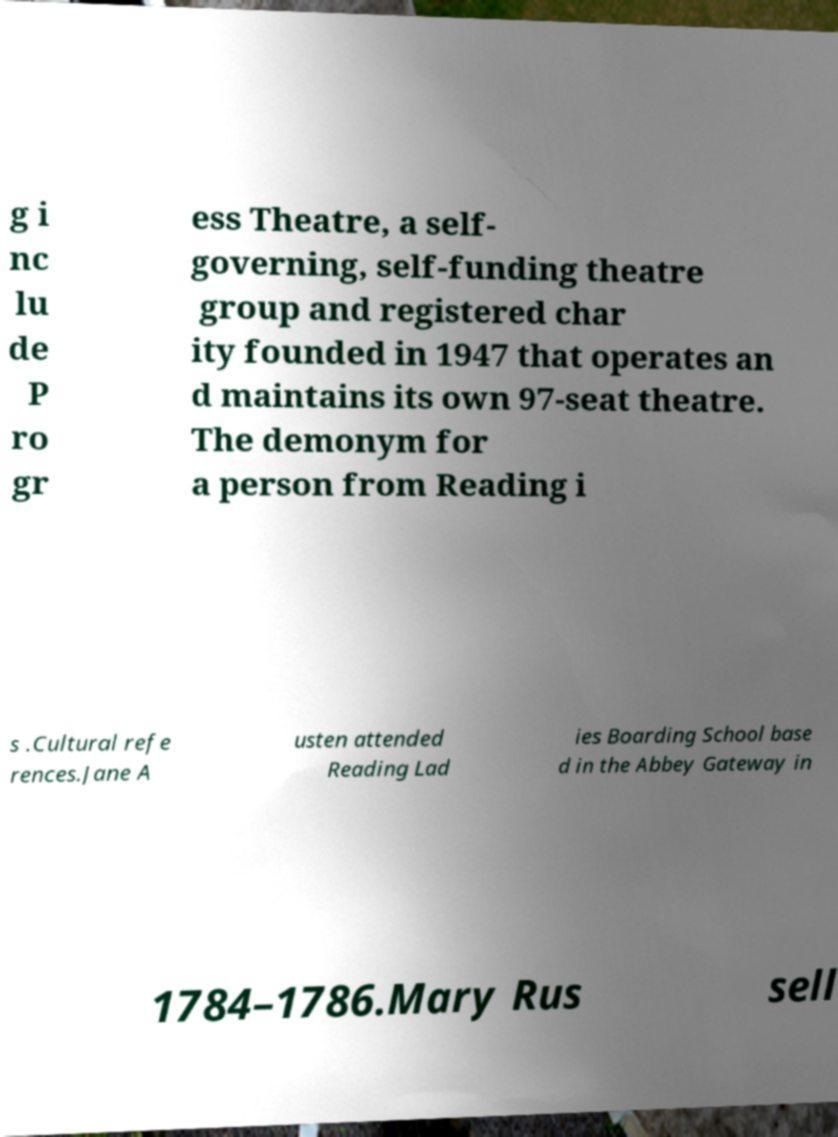Please read and relay the text visible in this image. What does it say? g i nc lu de P ro gr ess Theatre, a self- governing, self-funding theatre group and registered char ity founded in 1947 that operates an d maintains its own 97-seat theatre. The demonym for a person from Reading i s .Cultural refe rences.Jane A usten attended Reading Lad ies Boarding School base d in the Abbey Gateway in 1784–1786.Mary Rus sell 